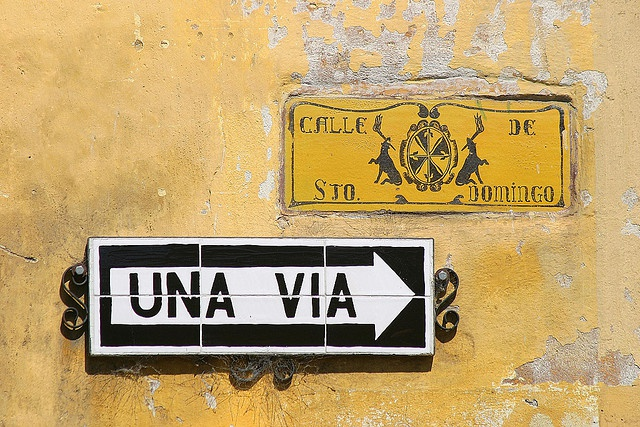Describe the objects in this image and their specific colors. I can see various objects in this image with different colors. 